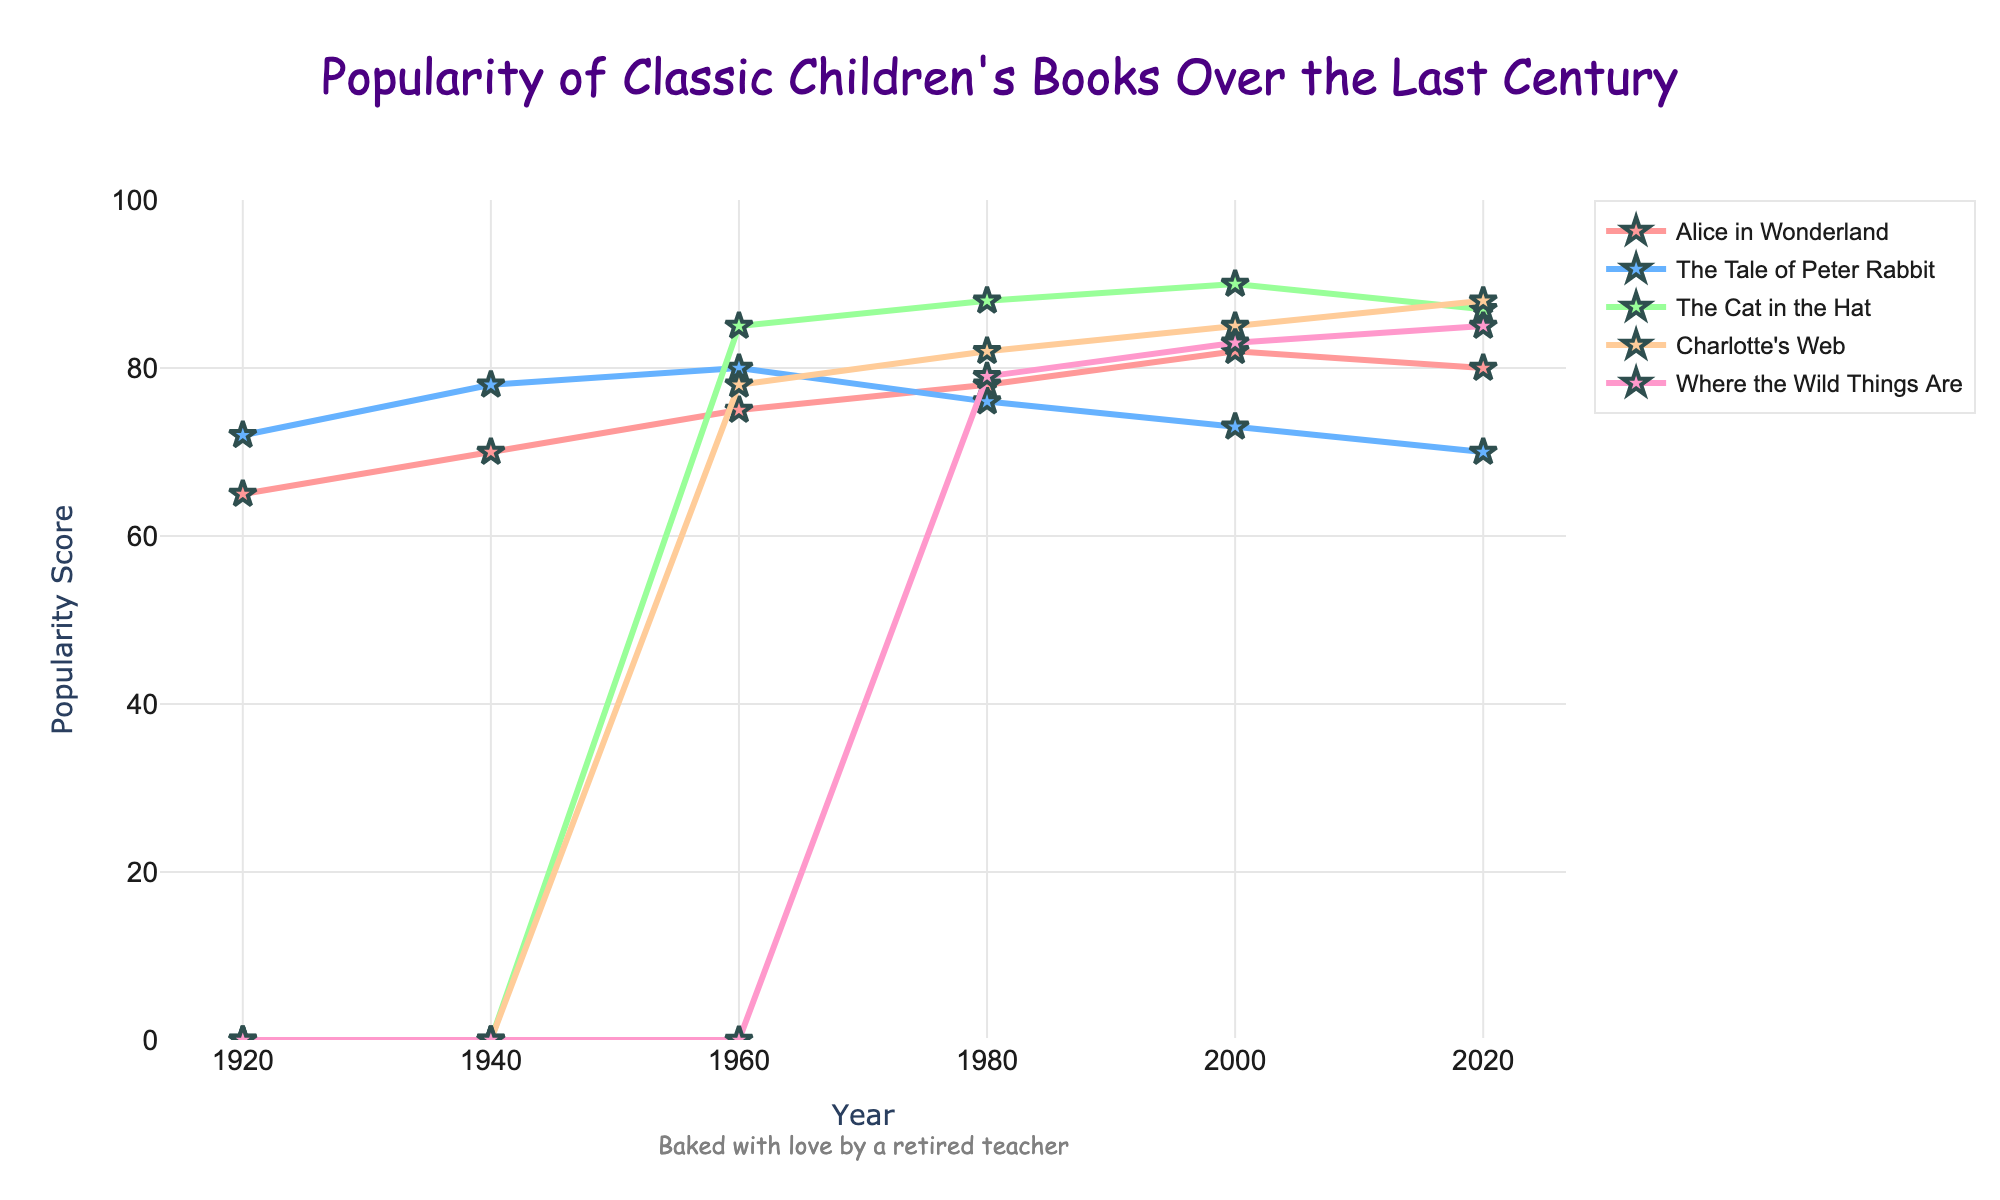Which book experienced the greatest increase in popularity between 1940 and 1960? To determine this, look at the popularity scores for each book in 1940 and 1960 and find the difference. Alice in Wonderland increased by 5 points, The Tale of Peter Rabbit by 2 points, The Cat in the Hat wasn't available in 1940, and Charlotte's Web increased by 78 points.
Answer: Charlotte's Web Between 1980 and 2000, which book's popularity decreased the most? Check the popularity scores of each book in 1980 and 2000, then subtract the 2000 values from the 1980 values. Alice in Wonderland decreased by 2 points, The Tale of Peter Rabbit by 3 points, The Cat in the Hat increased by 2 points, Charlotte's Web increased by 3 points, and Where the Wild Things Are increased by 4 points. Therefore, The Tale of Peter Rabbit's popularity decreased the most.
Answer: The Tale of Peter Rabbit Which book had the highest initial popularity score in 1920? Look at the scores for each book in 1920. Alice in Wonderland had a score of 65, and The Tale of Peter Rabbit had a score of 72. The other books were not published yet.
Answer: The Tale of Peter Rabbit What is the average popularity score of "Where the Wild Things Are" from 1980 to 2020? Sum the popularity scores for "Where the Wild Things Are" from 1980 (79), 2000 (83), and 2020 (85), then divide by the number of data points (3). (79 + 83 + 85) / 3 equals 82.33
Answer: 82.33 Which book's popularity remained stable or nearly stable between 2000 and 2020? Compare the popularity scores from 2000 to 2020 for each book. Alice in Wonderland decreased by 2 points (82 to 80), The Tale of Peter Rabbit decreased by 3 points (73 to 70), The Cat in the Hat decreased by 3 points (90 to 87), Charlotte's Web increased by 3 points (85 to 88), and Where the Wild Things Are increased by 2 points (83 to 85). Therefore, Alice in Wonderland and Where the Wild Things Are remained the most stable.
Answer: Alice in Wonderland and Where the Wild Things Are 